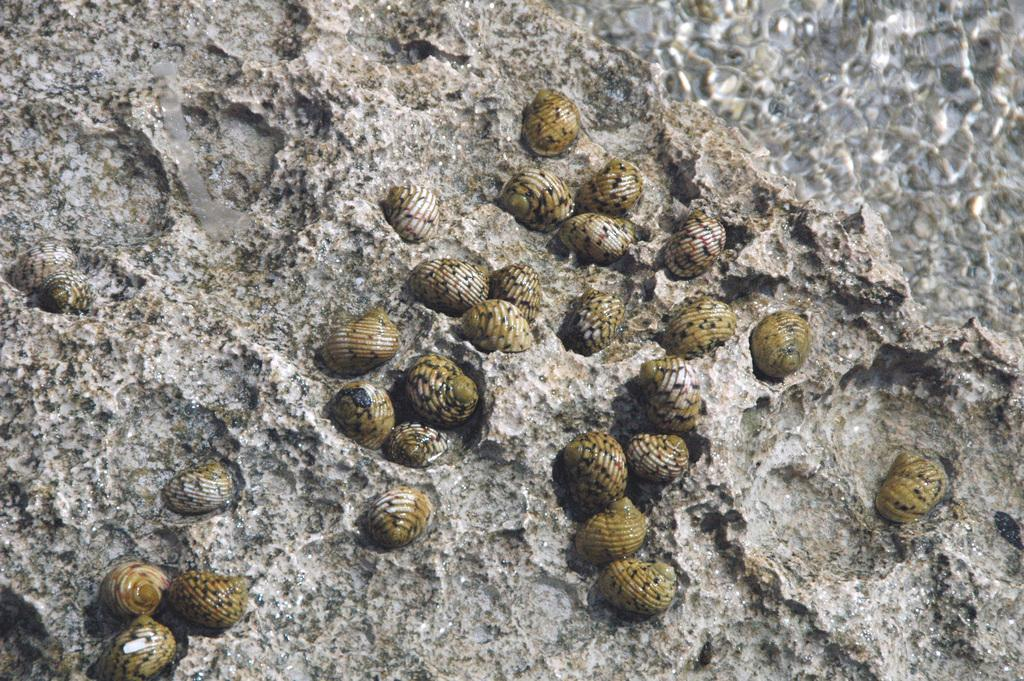What type of objects can be seen in the image? There are shells in the image. What is at the bottom of the image? There is sand at the bottom of the image. What shape can be seen in the image? There is no specific shape mentioned in the facts provided, so we cannot determine the shape of any object in the image. 